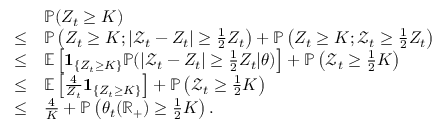Convert formula to latex. <formula><loc_0><loc_0><loc_500><loc_500>\begin{array} { r l } & { \mathbb { P } ( Z _ { t } \geq K ) } \\ { \leq } & { \mathbb { P } \left ( Z _ { t } \geq K ; | \mathcal { Z } _ { t } - Z _ { t } | \geq \frac { 1 } { 2 } Z _ { t } \right ) + \mathbb { P } \left ( Z _ { t } \geq K ; \mathcal { Z } _ { t } \geq \frac { 1 } { 2 } Z _ { t } \right ) } \\ { \leq } & { \mathbb { E } \left [ 1 _ { \left \{ Z _ { t } \geq K \right \} } \mathbb { P } ( | \mathcal { Z } _ { t } - Z _ { t } | \geq \frac { 1 } { 2 } Z _ { t } | \theta ) \right ] + \mathbb { P } \left ( \mathcal { Z } _ { t } \geq \frac { 1 } { 2 } K \right ) } \\ { \leq } & { \mathbb { E } \left [ \frac { 4 } { Z _ { t } } 1 _ { \left \{ Z _ { t } \geq K \right \} } \right ] + \mathbb { P } \left ( \mathcal { Z } _ { t } \geq \frac { 1 } { 2 } K \right ) } \\ { \leq } & { \frac { 4 } { K } + \mathbb { P } \left ( \theta _ { t } ( \mathbb { R } _ { + } ) \geq \frac { 1 } { 2 } K \right ) . } \end{array}</formula> 